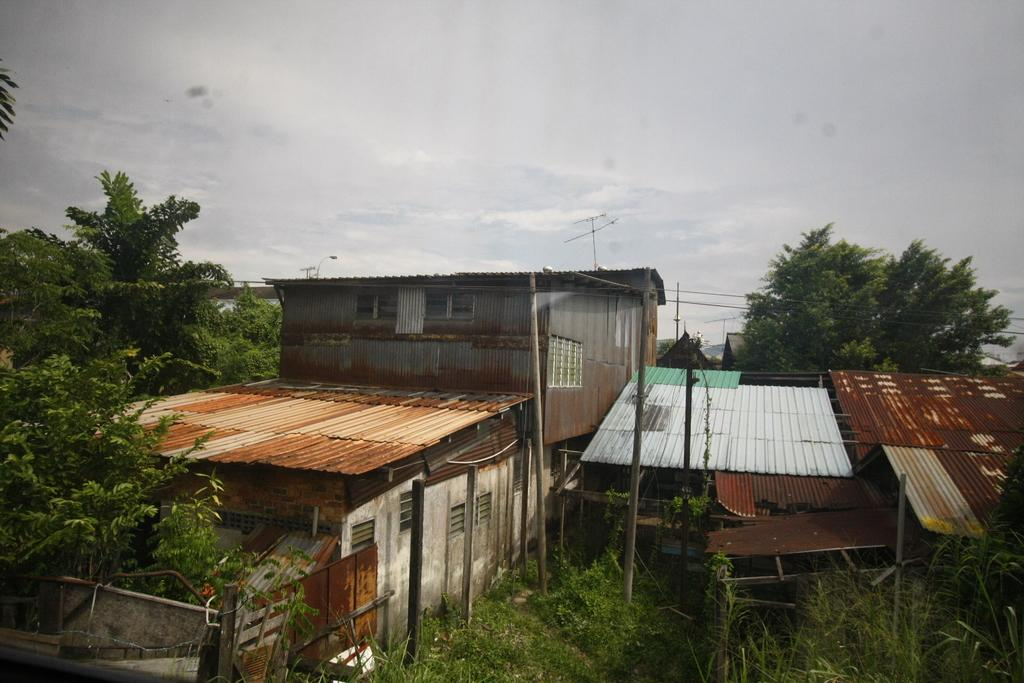What type of structures can be seen near the image? There are houses near the image. What type of vegetation is present in the image? There are plants and trees in the image. Can you describe the plants beside the image? There are plants beside the image, but their specific characteristics are not mentioned in the facts. What is visible in the background of the image? The sky is visible in the background of the image. What can be seen in the sky? Clouds are present in the sky. What type of society is depicted in the image? The image does not depict a society; it features houses, plants, trees, and a sky with clouds. Can you tell me how many women are present in the image? There is no mention of a woman or any people in the image. 